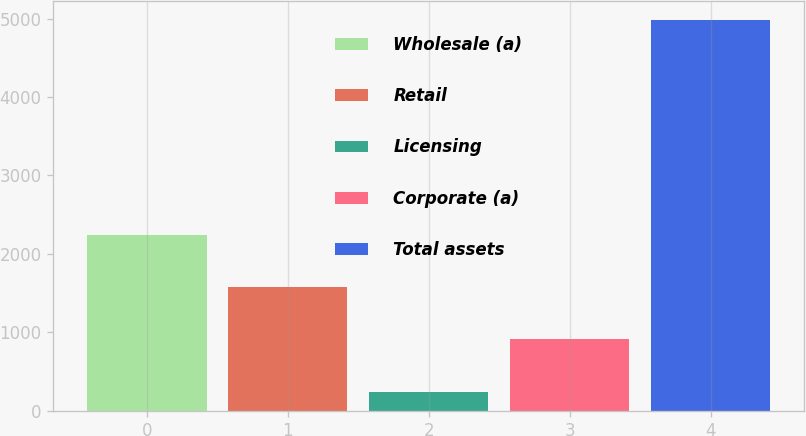Convert chart. <chart><loc_0><loc_0><loc_500><loc_500><bar_chart><fcel>Wholesale (a)<fcel>Retail<fcel>Licensing<fcel>Corporate (a)<fcel>Total assets<nl><fcel>2242.6<fcel>1581.4<fcel>238.1<fcel>919<fcel>4981.1<nl></chart> 